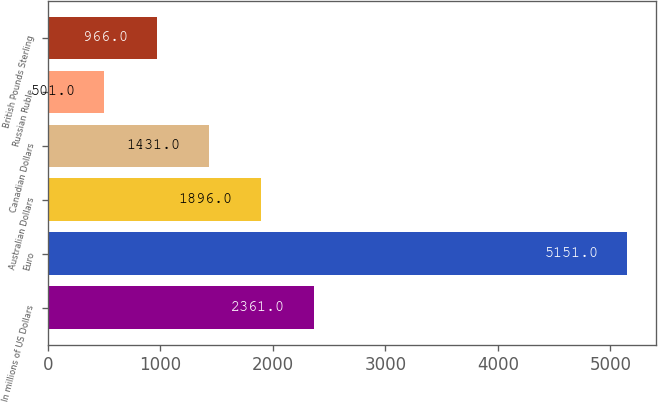<chart> <loc_0><loc_0><loc_500><loc_500><bar_chart><fcel>In millions of US Dollars<fcel>Euro<fcel>Australian Dollars<fcel>Canadian Dollars<fcel>Russian Ruble<fcel>British Pounds Sterling<nl><fcel>2361<fcel>5151<fcel>1896<fcel>1431<fcel>501<fcel>966<nl></chart> 